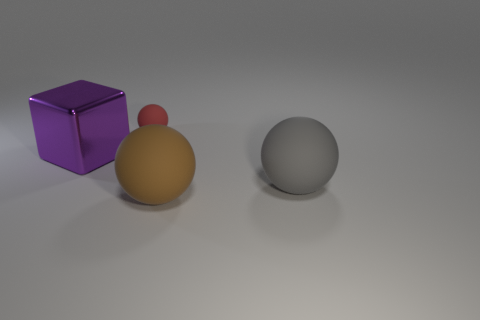Do the tiny sphere and the large cube have the same color?
Your answer should be very brief. No. The brown object that is the same size as the purple cube is what shape?
Keep it short and to the point. Sphere. The gray object has what size?
Your response must be concise. Large. Is the size of the object that is to the left of the tiny rubber sphere the same as the object behind the block?
Your answer should be compact. No. There is a sphere that is right of the thing that is in front of the big gray thing; what is its color?
Offer a very short reply. Gray. There is a gray thing that is the same size as the brown object; what material is it?
Your response must be concise. Rubber. How many metal objects are big red objects or large brown things?
Make the answer very short. 0. There is a sphere that is both behind the brown thing and right of the red matte ball; what color is it?
Your response must be concise. Gray. There is a red rubber object; how many small rubber things are to the right of it?
Your answer should be very brief. 0. What is the gray sphere made of?
Your answer should be compact. Rubber. 